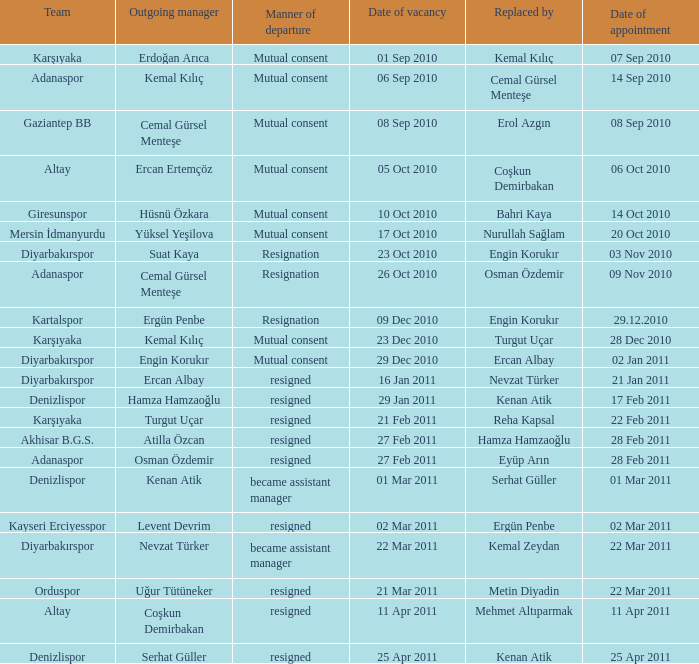Could you parse the entire table as a dict? {'header': ['Team', 'Outgoing manager', 'Manner of departure', 'Date of vacancy', 'Replaced by', 'Date of appointment'], 'rows': [['Karşıyaka', 'Erdoğan Arıca', 'Mutual consent', '01 Sep 2010', 'Kemal Kılıç', '07 Sep 2010'], ['Adanaspor', 'Kemal Kılıç', 'Mutual consent', '06 Sep 2010', 'Cemal Gürsel Menteşe', '14 Sep 2010'], ['Gaziantep BB', 'Cemal Gürsel Menteşe', 'Mutual consent', '08 Sep 2010', 'Erol Azgın', '08 Sep 2010'], ['Altay', 'Ercan Ertemçöz', 'Mutual consent', '05 Oct 2010', 'Coşkun Demirbakan', '06 Oct 2010'], ['Giresunspor', 'Hüsnü Özkara', 'Mutual consent', '10 Oct 2010', 'Bahri Kaya', '14 Oct 2010'], ['Mersin İdmanyurdu', 'Yüksel Yeşilova', 'Mutual consent', '17 Oct 2010', 'Nurullah Sağlam', '20 Oct 2010'], ['Diyarbakırspor', 'Suat Kaya', 'Resignation', '23 Oct 2010', 'Engin Korukır', '03 Nov 2010'], ['Adanaspor', 'Cemal Gürsel Menteşe', 'Resignation', '26 Oct 2010', 'Osman Özdemir', '09 Nov 2010'], ['Kartalspor', 'Ergün Penbe', 'Resignation', '09 Dec 2010', 'Engin Korukır', '29.12.2010'], ['Karşıyaka', 'Kemal Kılıç', 'Mutual consent', '23 Dec 2010', 'Turgut Uçar', '28 Dec 2010'], ['Diyarbakırspor', 'Engin Korukır', 'Mutual consent', '29 Dec 2010', 'Ercan Albay', '02 Jan 2011'], ['Diyarbakırspor', 'Ercan Albay', 'resigned', '16 Jan 2011', 'Nevzat Türker', '21 Jan 2011'], ['Denizlispor', 'Hamza Hamzaoğlu', 'resigned', '29 Jan 2011', 'Kenan Atik', '17 Feb 2011'], ['Karşıyaka', 'Turgut Uçar', 'resigned', '21 Feb 2011', 'Reha Kapsal', '22 Feb 2011'], ['Akhisar B.G.S.', 'Atilla Özcan', 'resigned', '27 Feb 2011', 'Hamza Hamzaoğlu', '28 Feb 2011'], ['Adanaspor', 'Osman Özdemir', 'resigned', '27 Feb 2011', 'Eyüp Arın', '28 Feb 2011'], ['Denizlispor', 'Kenan Atik', 'became assistant manager', '01 Mar 2011', 'Serhat Güller', '01 Mar 2011'], ['Kayseri Erciyesspor', 'Levent Devrim', 'resigned', '02 Mar 2011', 'Ergün Penbe', '02 Mar 2011'], ['Diyarbakırspor', 'Nevzat Türker', 'became assistant manager', '22 Mar 2011', 'Kemal Zeydan', '22 Mar 2011'], ['Orduspor', 'Uğur Tütüneker', 'resigned', '21 Mar 2011', 'Metin Diyadin', '22 Mar 2011'], ['Altay', 'Coşkun Demirbakan', 'resigned', '11 Apr 2011', 'Mehmet Altıparmak', '11 Apr 2011'], ['Denizlispor', 'Serhat Güller', 'resigned', '25 Apr 2011', 'Kenan Atik', '25 Apr 2011']]} Who replaced the outgoing manager Hüsnü Özkara?  Bahri Kaya. 